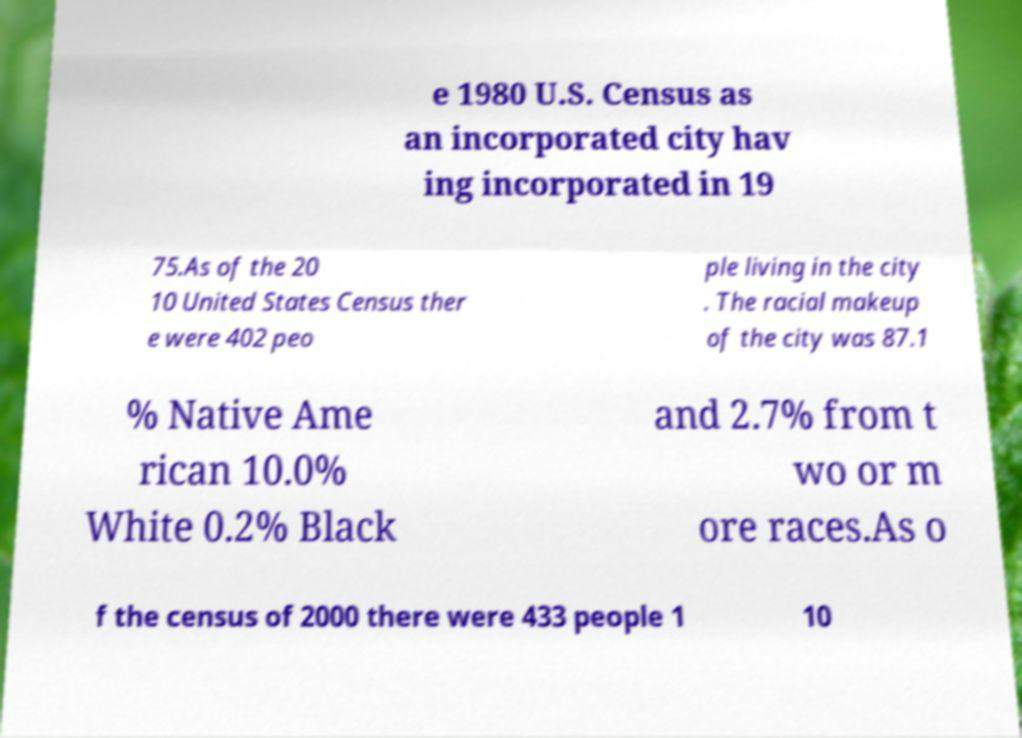Please read and relay the text visible in this image. What does it say? e 1980 U.S. Census as an incorporated city hav ing incorporated in 19 75.As of the 20 10 United States Census ther e were 402 peo ple living in the city . The racial makeup of the city was 87.1 % Native Ame rican 10.0% White 0.2% Black and 2.7% from t wo or m ore races.As o f the census of 2000 there were 433 people 1 10 